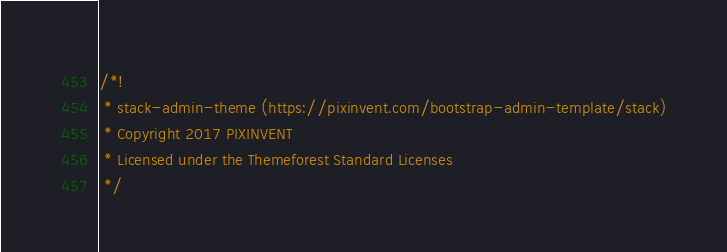Convert code to text. <code><loc_0><loc_0><loc_500><loc_500><_JavaScript_>/*!
 * stack-admin-theme (https://pixinvent.com/bootstrap-admin-template/stack)
 * Copyright 2017 PIXINVENT
 * Licensed under the Themeforest Standard Licenses
 */</code> 